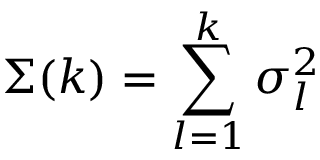Convert formula to latex. <formula><loc_0><loc_0><loc_500><loc_500>\Sigma ( k ) = \sum _ { l = 1 } ^ { k } \sigma _ { l } ^ { 2 }</formula> 